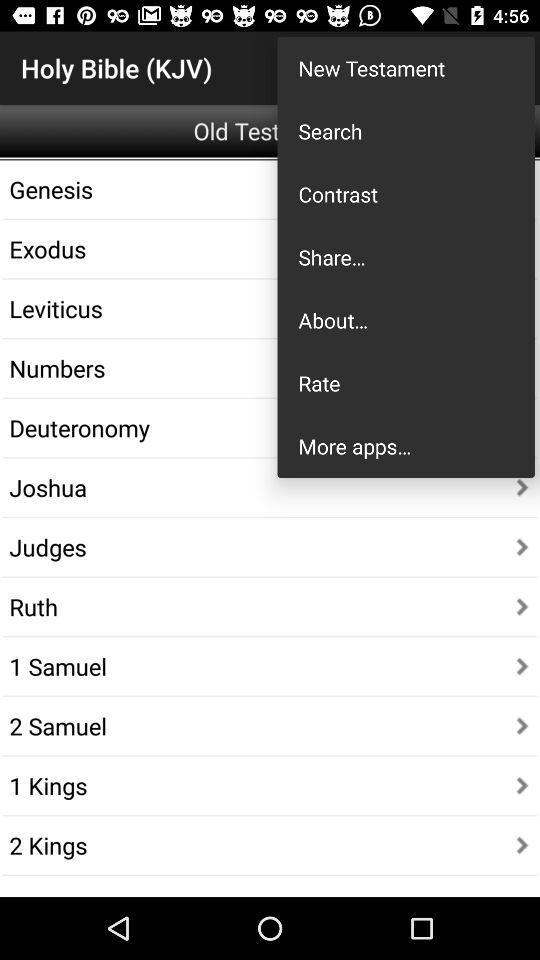What is the application name? The application name is "Holy Bible (KJV)". 